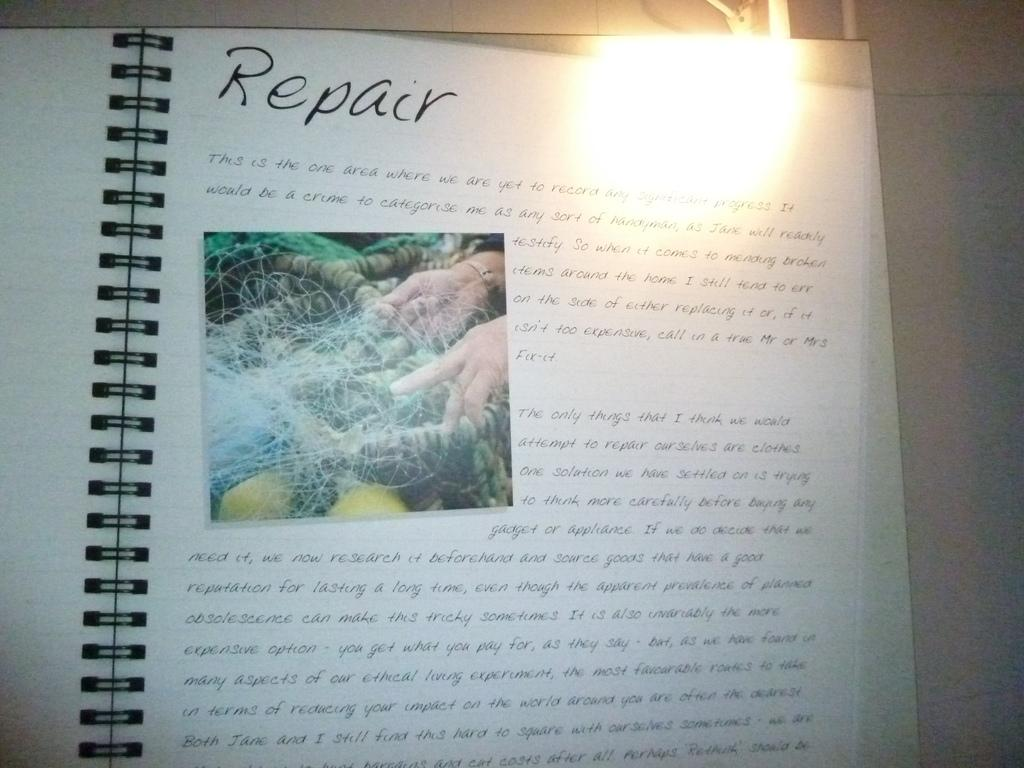<image>
Write a terse but informative summary of the picture. an open book to the word Repair has an overexposed corner 